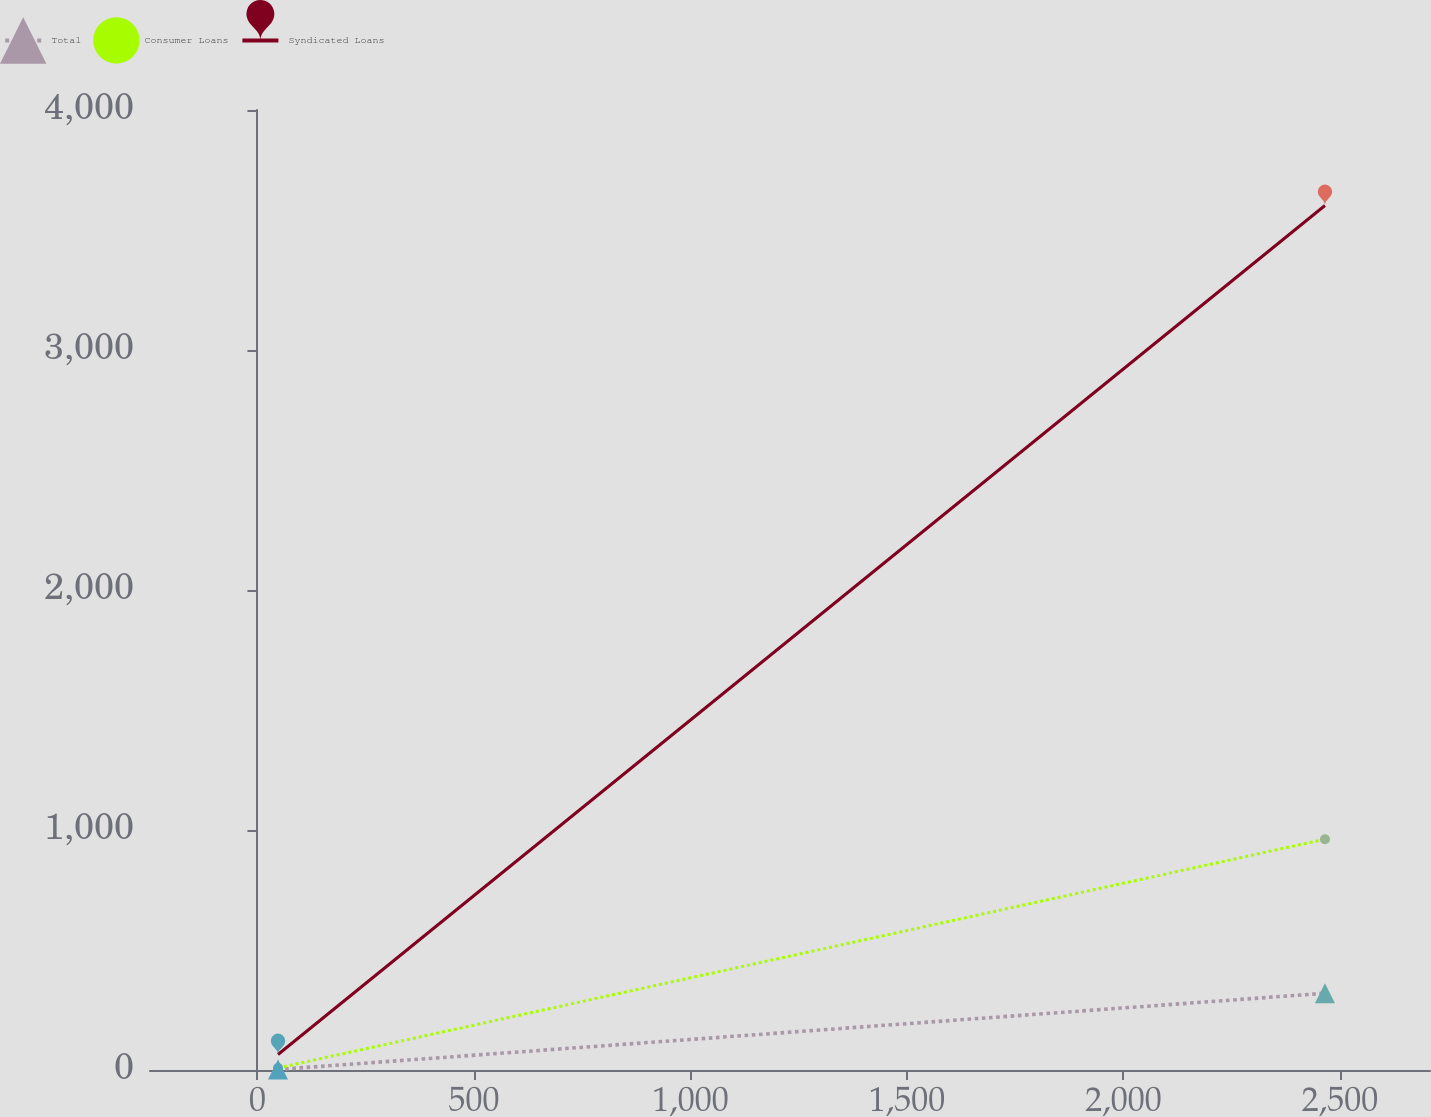Convert chart. <chart><loc_0><loc_0><loc_500><loc_500><line_chart><ecel><fcel>Total<fcel>Consumer Loans<fcel>Syndicated Loans<nl><fcel>47.5<fcel>2.19<fcel>8.64<fcel>64.42<nl><fcel>2465.42<fcel>319.79<fcel>961.57<fcel>3602.19<nl><fcel>3003.61<fcel>290.1<fcel>1117.05<fcel>4107.33<nl></chart> 